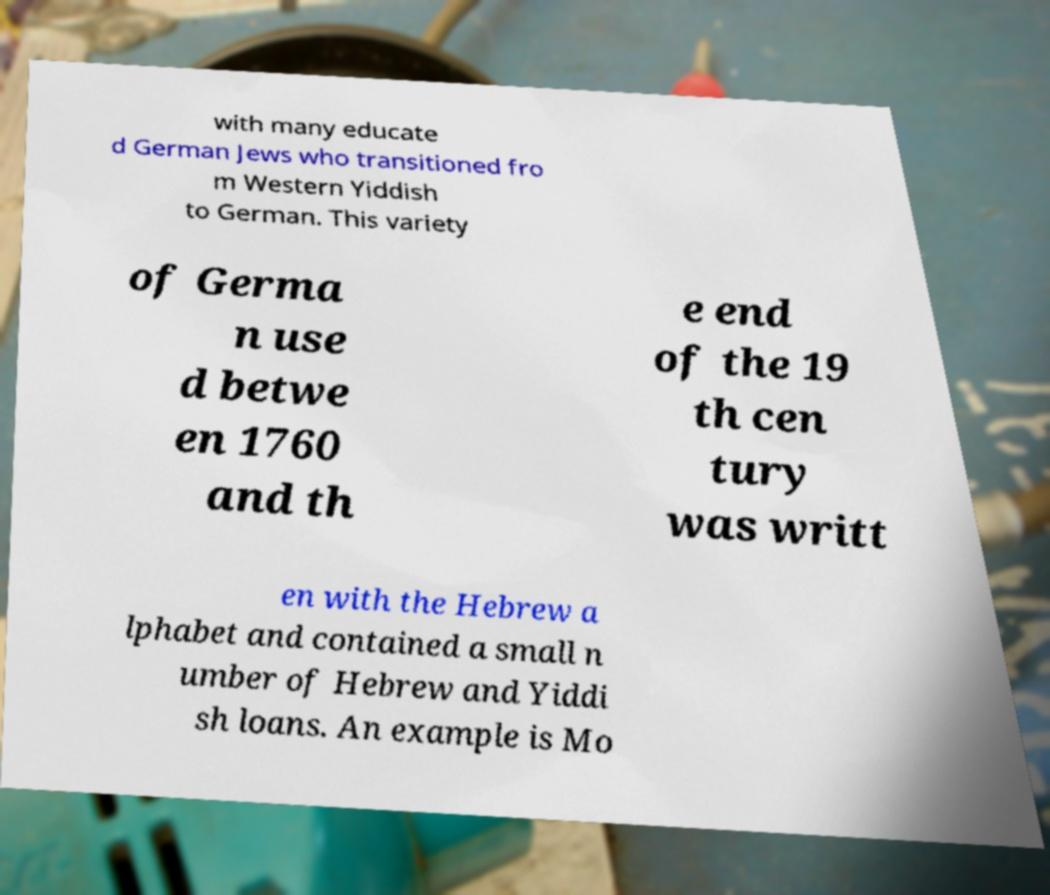I need the written content from this picture converted into text. Can you do that? with many educate d German Jews who transitioned fro m Western Yiddish to German. This variety of Germa n use d betwe en 1760 and th e end of the 19 th cen tury was writt en with the Hebrew a lphabet and contained a small n umber of Hebrew and Yiddi sh loans. An example is Mo 